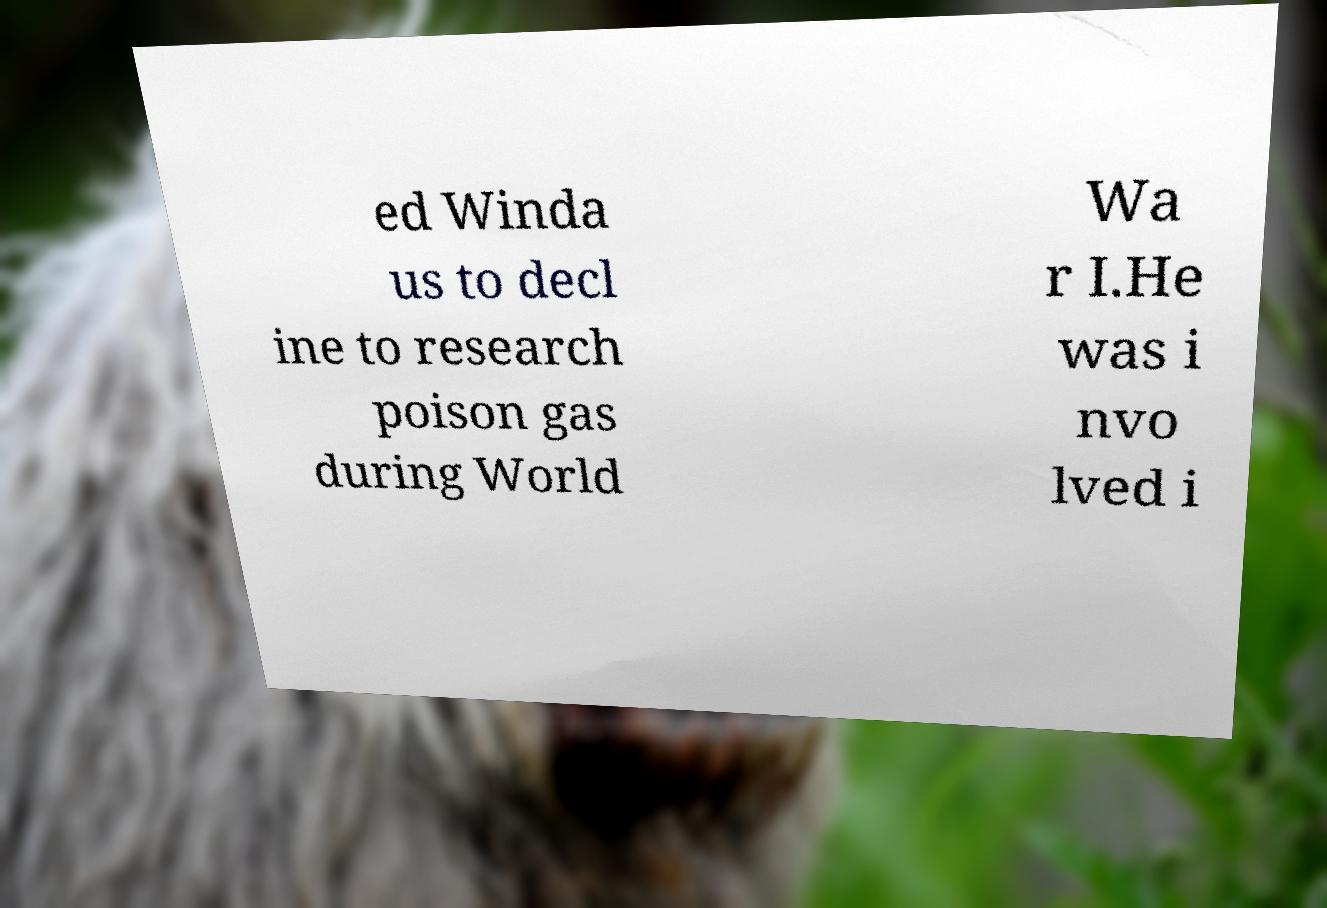Please read and relay the text visible in this image. What does it say? ed Winda us to decl ine to research poison gas during World Wa r I.He was i nvo lved i 